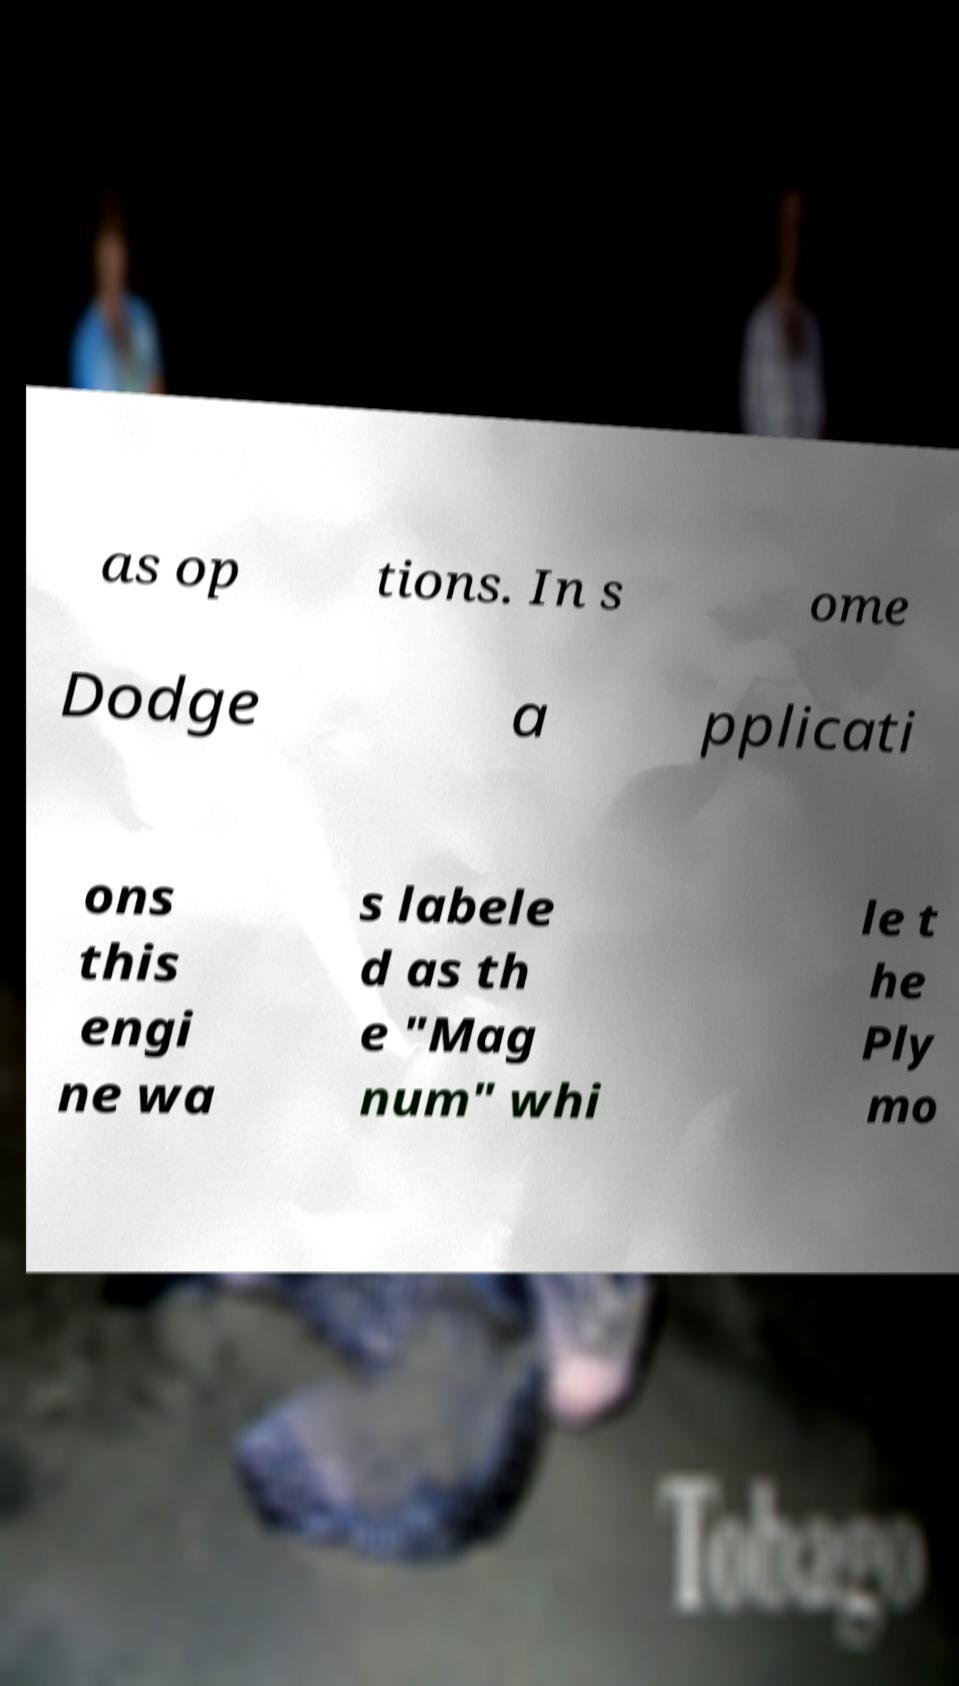Could you extract and type out the text from this image? as op tions. In s ome Dodge a pplicati ons this engi ne wa s labele d as th e "Mag num" whi le t he Ply mo 